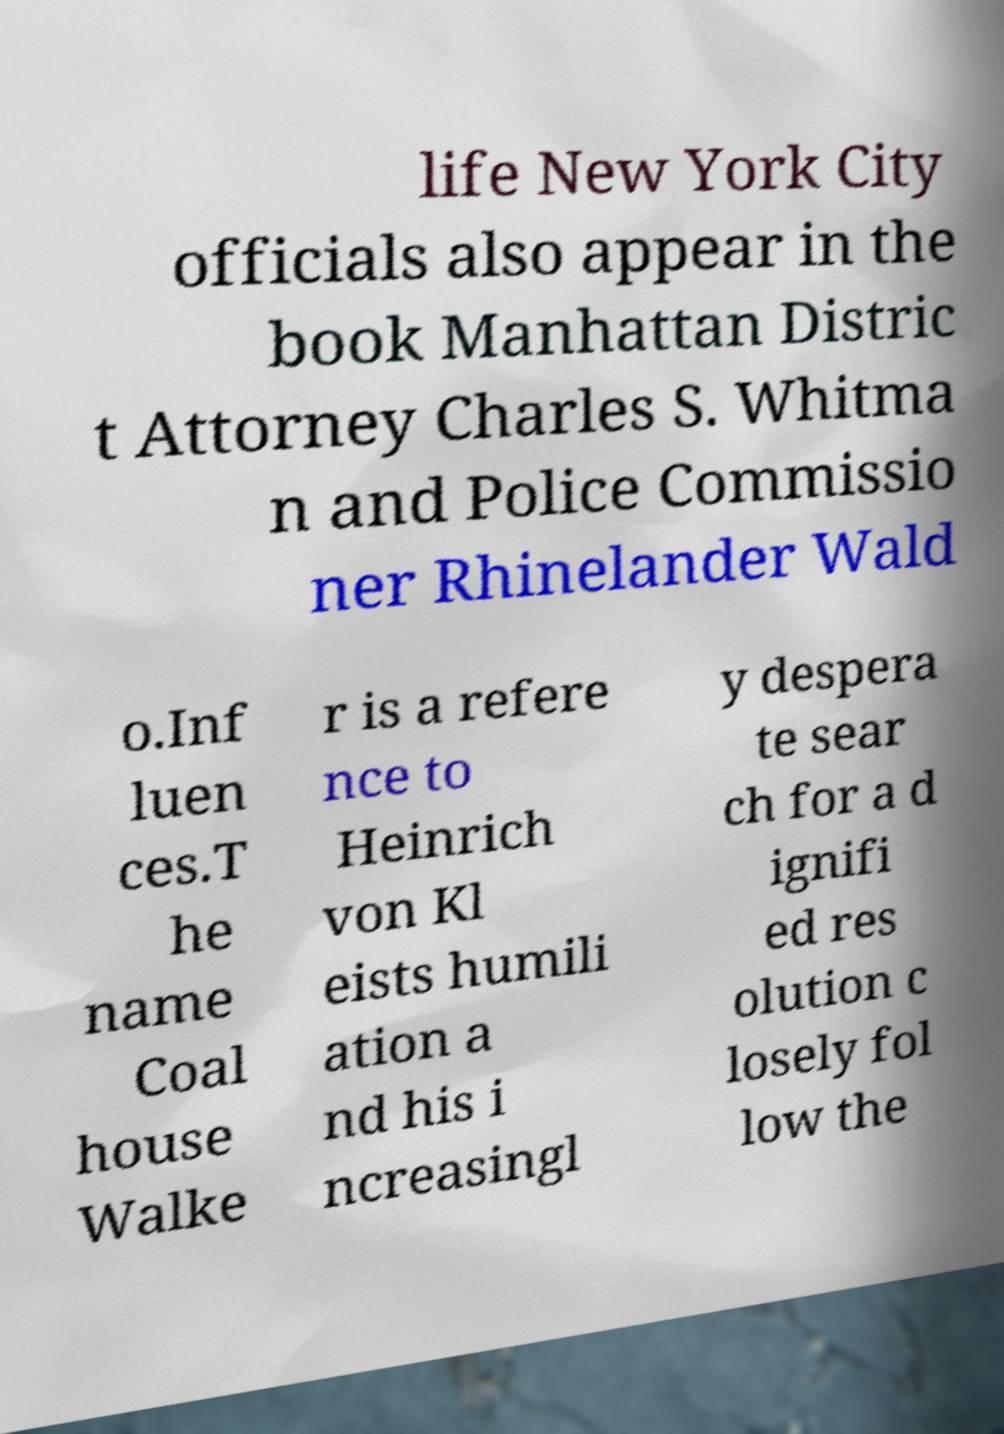What messages or text are displayed in this image? I need them in a readable, typed format. life New York City officials also appear in the book Manhattan Distric t Attorney Charles S. Whitma n and Police Commissio ner Rhinelander Wald o.Inf luen ces.T he name Coal house Walke r is a refere nce to Heinrich von Kl eists humili ation a nd his i ncreasingl y despera te sear ch for a d ignifi ed res olution c losely fol low the 